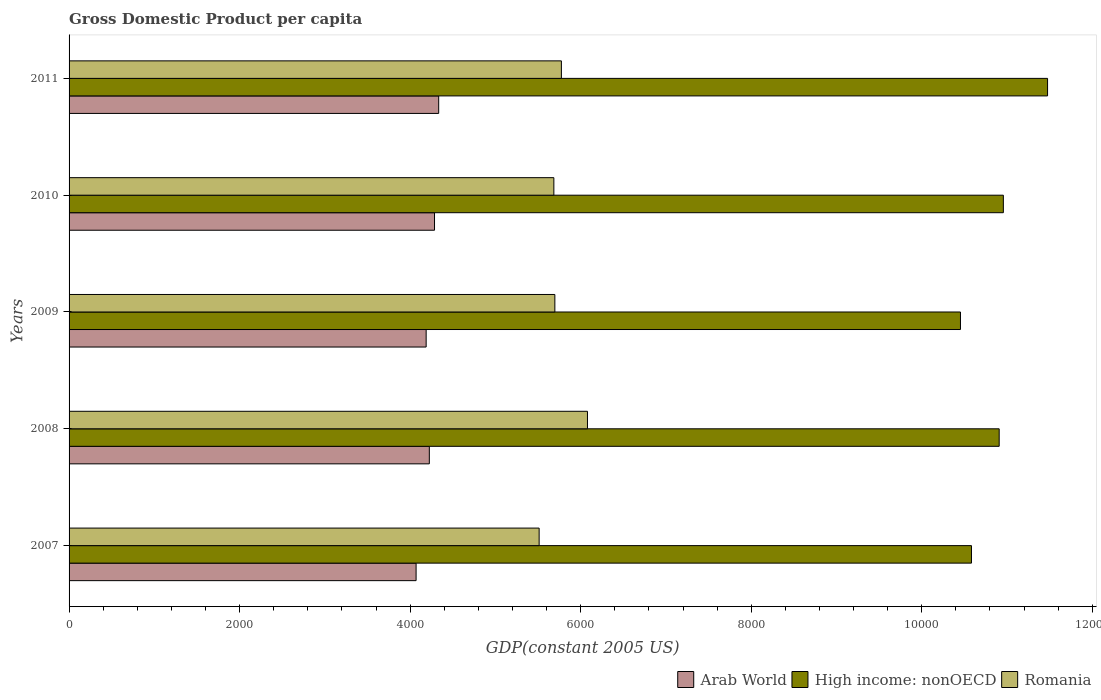How many different coloured bars are there?
Offer a very short reply. 3. Are the number of bars per tick equal to the number of legend labels?
Your answer should be compact. Yes. In how many cases, is the number of bars for a given year not equal to the number of legend labels?
Offer a very short reply. 0. What is the GDP per capita in Arab World in 2007?
Your answer should be compact. 4069.83. Across all years, what is the maximum GDP per capita in High income: nonOECD?
Give a very brief answer. 1.15e+04. Across all years, what is the minimum GDP per capita in Arab World?
Provide a short and direct response. 4069.83. In which year was the GDP per capita in High income: nonOECD maximum?
Your answer should be very brief. 2011. In which year was the GDP per capita in Arab World minimum?
Your response must be concise. 2007. What is the total GDP per capita in Romania in the graph?
Ensure brevity in your answer.  2.87e+04. What is the difference between the GDP per capita in Romania in 2010 and that in 2011?
Your answer should be very brief. -88.38. What is the difference between the GDP per capita in Romania in 2010 and the GDP per capita in High income: nonOECD in 2007?
Your answer should be very brief. -4897.54. What is the average GDP per capita in High income: nonOECD per year?
Keep it short and to the point. 1.09e+04. In the year 2007, what is the difference between the GDP per capita in High income: nonOECD and GDP per capita in Romania?
Make the answer very short. 5070.15. What is the ratio of the GDP per capita in High income: nonOECD in 2007 to that in 2010?
Give a very brief answer. 0.97. Is the difference between the GDP per capita in High income: nonOECD in 2009 and 2010 greater than the difference between the GDP per capita in Romania in 2009 and 2010?
Give a very brief answer. No. What is the difference between the highest and the second highest GDP per capita in High income: nonOECD?
Make the answer very short. 518.52. What is the difference between the highest and the lowest GDP per capita in Romania?
Offer a terse response. 566.79. In how many years, is the GDP per capita in High income: nonOECD greater than the average GDP per capita in High income: nonOECD taken over all years?
Provide a succinct answer. 3. Is the sum of the GDP per capita in High income: nonOECD in 2008 and 2010 greater than the maximum GDP per capita in Romania across all years?
Your answer should be very brief. Yes. What does the 3rd bar from the top in 2011 represents?
Provide a succinct answer. Arab World. What does the 3rd bar from the bottom in 2009 represents?
Provide a short and direct response. Romania. Are all the bars in the graph horizontal?
Give a very brief answer. Yes. How many legend labels are there?
Your answer should be very brief. 3. How are the legend labels stacked?
Keep it short and to the point. Horizontal. What is the title of the graph?
Provide a short and direct response. Gross Domestic Product per capita. Does "High income" appear as one of the legend labels in the graph?
Provide a succinct answer. No. What is the label or title of the X-axis?
Your answer should be very brief. GDP(constant 2005 US). What is the GDP(constant 2005 US) in Arab World in 2007?
Offer a very short reply. 4069.83. What is the GDP(constant 2005 US) of High income: nonOECD in 2007?
Provide a short and direct response. 1.06e+04. What is the GDP(constant 2005 US) of Romania in 2007?
Your answer should be very brief. 5512.77. What is the GDP(constant 2005 US) of Arab World in 2008?
Offer a very short reply. 4224.99. What is the GDP(constant 2005 US) of High income: nonOECD in 2008?
Keep it short and to the point. 1.09e+04. What is the GDP(constant 2005 US) in Romania in 2008?
Provide a succinct answer. 6079.56. What is the GDP(constant 2005 US) in Arab World in 2009?
Offer a terse response. 4187.73. What is the GDP(constant 2005 US) in High income: nonOECD in 2009?
Make the answer very short. 1.05e+04. What is the GDP(constant 2005 US) of Romania in 2009?
Give a very brief answer. 5697.19. What is the GDP(constant 2005 US) of Arab World in 2010?
Provide a succinct answer. 4285.82. What is the GDP(constant 2005 US) of High income: nonOECD in 2010?
Provide a short and direct response. 1.10e+04. What is the GDP(constant 2005 US) of Romania in 2010?
Make the answer very short. 5685.37. What is the GDP(constant 2005 US) in Arab World in 2011?
Offer a very short reply. 4334.68. What is the GDP(constant 2005 US) of High income: nonOECD in 2011?
Offer a very short reply. 1.15e+04. What is the GDP(constant 2005 US) of Romania in 2011?
Ensure brevity in your answer.  5773.76. Across all years, what is the maximum GDP(constant 2005 US) in Arab World?
Your response must be concise. 4334.68. Across all years, what is the maximum GDP(constant 2005 US) in High income: nonOECD?
Offer a terse response. 1.15e+04. Across all years, what is the maximum GDP(constant 2005 US) in Romania?
Your answer should be very brief. 6079.56. Across all years, what is the minimum GDP(constant 2005 US) in Arab World?
Your response must be concise. 4069.83. Across all years, what is the minimum GDP(constant 2005 US) of High income: nonOECD?
Provide a succinct answer. 1.05e+04. Across all years, what is the minimum GDP(constant 2005 US) in Romania?
Provide a short and direct response. 5512.77. What is the total GDP(constant 2005 US) of Arab World in the graph?
Your answer should be very brief. 2.11e+04. What is the total GDP(constant 2005 US) of High income: nonOECD in the graph?
Offer a very short reply. 5.44e+04. What is the total GDP(constant 2005 US) in Romania in the graph?
Your answer should be very brief. 2.87e+04. What is the difference between the GDP(constant 2005 US) in Arab World in 2007 and that in 2008?
Your answer should be compact. -155.16. What is the difference between the GDP(constant 2005 US) of High income: nonOECD in 2007 and that in 2008?
Provide a short and direct response. -325.05. What is the difference between the GDP(constant 2005 US) of Romania in 2007 and that in 2008?
Your response must be concise. -566.79. What is the difference between the GDP(constant 2005 US) of Arab World in 2007 and that in 2009?
Offer a terse response. -117.9. What is the difference between the GDP(constant 2005 US) of High income: nonOECD in 2007 and that in 2009?
Your response must be concise. 128.96. What is the difference between the GDP(constant 2005 US) in Romania in 2007 and that in 2009?
Give a very brief answer. -184.43. What is the difference between the GDP(constant 2005 US) in Arab World in 2007 and that in 2010?
Your answer should be very brief. -215.99. What is the difference between the GDP(constant 2005 US) in High income: nonOECD in 2007 and that in 2010?
Make the answer very short. -373.98. What is the difference between the GDP(constant 2005 US) in Romania in 2007 and that in 2010?
Keep it short and to the point. -172.61. What is the difference between the GDP(constant 2005 US) of Arab World in 2007 and that in 2011?
Make the answer very short. -264.85. What is the difference between the GDP(constant 2005 US) of High income: nonOECD in 2007 and that in 2011?
Your response must be concise. -892.5. What is the difference between the GDP(constant 2005 US) of Romania in 2007 and that in 2011?
Keep it short and to the point. -260.99. What is the difference between the GDP(constant 2005 US) in Arab World in 2008 and that in 2009?
Provide a short and direct response. 37.26. What is the difference between the GDP(constant 2005 US) of High income: nonOECD in 2008 and that in 2009?
Provide a short and direct response. 454.01. What is the difference between the GDP(constant 2005 US) of Romania in 2008 and that in 2009?
Provide a short and direct response. 382.37. What is the difference between the GDP(constant 2005 US) of Arab World in 2008 and that in 2010?
Provide a succinct answer. -60.83. What is the difference between the GDP(constant 2005 US) of High income: nonOECD in 2008 and that in 2010?
Your response must be concise. -48.93. What is the difference between the GDP(constant 2005 US) in Romania in 2008 and that in 2010?
Keep it short and to the point. 394.19. What is the difference between the GDP(constant 2005 US) in Arab World in 2008 and that in 2011?
Ensure brevity in your answer.  -109.69. What is the difference between the GDP(constant 2005 US) of High income: nonOECD in 2008 and that in 2011?
Make the answer very short. -567.45. What is the difference between the GDP(constant 2005 US) of Romania in 2008 and that in 2011?
Your answer should be compact. 305.8. What is the difference between the GDP(constant 2005 US) of Arab World in 2009 and that in 2010?
Your response must be concise. -98.09. What is the difference between the GDP(constant 2005 US) of High income: nonOECD in 2009 and that in 2010?
Make the answer very short. -502.94. What is the difference between the GDP(constant 2005 US) of Romania in 2009 and that in 2010?
Offer a very short reply. 11.82. What is the difference between the GDP(constant 2005 US) in Arab World in 2009 and that in 2011?
Provide a succinct answer. -146.95. What is the difference between the GDP(constant 2005 US) of High income: nonOECD in 2009 and that in 2011?
Keep it short and to the point. -1021.46. What is the difference between the GDP(constant 2005 US) in Romania in 2009 and that in 2011?
Your answer should be compact. -76.56. What is the difference between the GDP(constant 2005 US) in Arab World in 2010 and that in 2011?
Keep it short and to the point. -48.86. What is the difference between the GDP(constant 2005 US) in High income: nonOECD in 2010 and that in 2011?
Provide a short and direct response. -518.52. What is the difference between the GDP(constant 2005 US) of Romania in 2010 and that in 2011?
Give a very brief answer. -88.38. What is the difference between the GDP(constant 2005 US) in Arab World in 2007 and the GDP(constant 2005 US) in High income: nonOECD in 2008?
Provide a succinct answer. -6838.14. What is the difference between the GDP(constant 2005 US) of Arab World in 2007 and the GDP(constant 2005 US) of Romania in 2008?
Make the answer very short. -2009.73. What is the difference between the GDP(constant 2005 US) in High income: nonOECD in 2007 and the GDP(constant 2005 US) in Romania in 2008?
Your answer should be very brief. 4503.36. What is the difference between the GDP(constant 2005 US) in Arab World in 2007 and the GDP(constant 2005 US) in High income: nonOECD in 2009?
Your answer should be compact. -6384.13. What is the difference between the GDP(constant 2005 US) of Arab World in 2007 and the GDP(constant 2005 US) of Romania in 2009?
Provide a succinct answer. -1627.36. What is the difference between the GDP(constant 2005 US) in High income: nonOECD in 2007 and the GDP(constant 2005 US) in Romania in 2009?
Your response must be concise. 4885.72. What is the difference between the GDP(constant 2005 US) of Arab World in 2007 and the GDP(constant 2005 US) of High income: nonOECD in 2010?
Offer a terse response. -6887.07. What is the difference between the GDP(constant 2005 US) in Arab World in 2007 and the GDP(constant 2005 US) in Romania in 2010?
Offer a very short reply. -1615.54. What is the difference between the GDP(constant 2005 US) of High income: nonOECD in 2007 and the GDP(constant 2005 US) of Romania in 2010?
Give a very brief answer. 4897.54. What is the difference between the GDP(constant 2005 US) of Arab World in 2007 and the GDP(constant 2005 US) of High income: nonOECD in 2011?
Provide a short and direct response. -7405.59. What is the difference between the GDP(constant 2005 US) of Arab World in 2007 and the GDP(constant 2005 US) of Romania in 2011?
Provide a succinct answer. -1703.93. What is the difference between the GDP(constant 2005 US) of High income: nonOECD in 2007 and the GDP(constant 2005 US) of Romania in 2011?
Provide a short and direct response. 4809.16. What is the difference between the GDP(constant 2005 US) of Arab World in 2008 and the GDP(constant 2005 US) of High income: nonOECD in 2009?
Your answer should be compact. -6228.97. What is the difference between the GDP(constant 2005 US) in Arab World in 2008 and the GDP(constant 2005 US) in Romania in 2009?
Ensure brevity in your answer.  -1472.21. What is the difference between the GDP(constant 2005 US) of High income: nonOECD in 2008 and the GDP(constant 2005 US) of Romania in 2009?
Your response must be concise. 5210.77. What is the difference between the GDP(constant 2005 US) in Arab World in 2008 and the GDP(constant 2005 US) in High income: nonOECD in 2010?
Your response must be concise. -6731.91. What is the difference between the GDP(constant 2005 US) of Arab World in 2008 and the GDP(constant 2005 US) of Romania in 2010?
Provide a succinct answer. -1460.38. What is the difference between the GDP(constant 2005 US) of High income: nonOECD in 2008 and the GDP(constant 2005 US) of Romania in 2010?
Ensure brevity in your answer.  5222.59. What is the difference between the GDP(constant 2005 US) of Arab World in 2008 and the GDP(constant 2005 US) of High income: nonOECD in 2011?
Ensure brevity in your answer.  -7250.43. What is the difference between the GDP(constant 2005 US) of Arab World in 2008 and the GDP(constant 2005 US) of Romania in 2011?
Offer a very short reply. -1548.77. What is the difference between the GDP(constant 2005 US) of High income: nonOECD in 2008 and the GDP(constant 2005 US) of Romania in 2011?
Make the answer very short. 5134.21. What is the difference between the GDP(constant 2005 US) of Arab World in 2009 and the GDP(constant 2005 US) of High income: nonOECD in 2010?
Offer a terse response. -6769.17. What is the difference between the GDP(constant 2005 US) in Arab World in 2009 and the GDP(constant 2005 US) in Romania in 2010?
Your response must be concise. -1497.64. What is the difference between the GDP(constant 2005 US) in High income: nonOECD in 2009 and the GDP(constant 2005 US) in Romania in 2010?
Provide a short and direct response. 4768.59. What is the difference between the GDP(constant 2005 US) of Arab World in 2009 and the GDP(constant 2005 US) of High income: nonOECD in 2011?
Offer a very short reply. -7287.69. What is the difference between the GDP(constant 2005 US) in Arab World in 2009 and the GDP(constant 2005 US) in Romania in 2011?
Offer a very short reply. -1586.03. What is the difference between the GDP(constant 2005 US) in High income: nonOECD in 2009 and the GDP(constant 2005 US) in Romania in 2011?
Ensure brevity in your answer.  4680.2. What is the difference between the GDP(constant 2005 US) of Arab World in 2010 and the GDP(constant 2005 US) of High income: nonOECD in 2011?
Give a very brief answer. -7189.6. What is the difference between the GDP(constant 2005 US) in Arab World in 2010 and the GDP(constant 2005 US) in Romania in 2011?
Give a very brief answer. -1487.94. What is the difference between the GDP(constant 2005 US) of High income: nonOECD in 2010 and the GDP(constant 2005 US) of Romania in 2011?
Make the answer very short. 5183.14. What is the average GDP(constant 2005 US) of Arab World per year?
Your response must be concise. 4220.61. What is the average GDP(constant 2005 US) of High income: nonOECD per year?
Your response must be concise. 1.09e+04. What is the average GDP(constant 2005 US) in Romania per year?
Your answer should be compact. 5749.73. In the year 2007, what is the difference between the GDP(constant 2005 US) of Arab World and GDP(constant 2005 US) of High income: nonOECD?
Make the answer very short. -6513.09. In the year 2007, what is the difference between the GDP(constant 2005 US) of Arab World and GDP(constant 2005 US) of Romania?
Offer a terse response. -1442.94. In the year 2007, what is the difference between the GDP(constant 2005 US) in High income: nonOECD and GDP(constant 2005 US) in Romania?
Offer a terse response. 5070.15. In the year 2008, what is the difference between the GDP(constant 2005 US) of Arab World and GDP(constant 2005 US) of High income: nonOECD?
Make the answer very short. -6682.98. In the year 2008, what is the difference between the GDP(constant 2005 US) in Arab World and GDP(constant 2005 US) in Romania?
Your answer should be compact. -1854.57. In the year 2008, what is the difference between the GDP(constant 2005 US) in High income: nonOECD and GDP(constant 2005 US) in Romania?
Make the answer very short. 4828.41. In the year 2009, what is the difference between the GDP(constant 2005 US) in Arab World and GDP(constant 2005 US) in High income: nonOECD?
Give a very brief answer. -6266.23. In the year 2009, what is the difference between the GDP(constant 2005 US) of Arab World and GDP(constant 2005 US) of Romania?
Your answer should be compact. -1509.46. In the year 2009, what is the difference between the GDP(constant 2005 US) of High income: nonOECD and GDP(constant 2005 US) of Romania?
Your answer should be very brief. 4756.77. In the year 2010, what is the difference between the GDP(constant 2005 US) in Arab World and GDP(constant 2005 US) in High income: nonOECD?
Your answer should be very brief. -6671.08. In the year 2010, what is the difference between the GDP(constant 2005 US) in Arab World and GDP(constant 2005 US) in Romania?
Offer a very short reply. -1399.55. In the year 2010, what is the difference between the GDP(constant 2005 US) of High income: nonOECD and GDP(constant 2005 US) of Romania?
Offer a very short reply. 5271.53. In the year 2011, what is the difference between the GDP(constant 2005 US) in Arab World and GDP(constant 2005 US) in High income: nonOECD?
Offer a terse response. -7140.74. In the year 2011, what is the difference between the GDP(constant 2005 US) in Arab World and GDP(constant 2005 US) in Romania?
Ensure brevity in your answer.  -1439.08. In the year 2011, what is the difference between the GDP(constant 2005 US) of High income: nonOECD and GDP(constant 2005 US) of Romania?
Offer a very short reply. 5701.66. What is the ratio of the GDP(constant 2005 US) in Arab World in 2007 to that in 2008?
Ensure brevity in your answer.  0.96. What is the ratio of the GDP(constant 2005 US) in High income: nonOECD in 2007 to that in 2008?
Offer a terse response. 0.97. What is the ratio of the GDP(constant 2005 US) of Romania in 2007 to that in 2008?
Your answer should be compact. 0.91. What is the ratio of the GDP(constant 2005 US) of Arab World in 2007 to that in 2009?
Keep it short and to the point. 0.97. What is the ratio of the GDP(constant 2005 US) of High income: nonOECD in 2007 to that in 2009?
Provide a succinct answer. 1.01. What is the ratio of the GDP(constant 2005 US) of Romania in 2007 to that in 2009?
Give a very brief answer. 0.97. What is the ratio of the GDP(constant 2005 US) in Arab World in 2007 to that in 2010?
Give a very brief answer. 0.95. What is the ratio of the GDP(constant 2005 US) of High income: nonOECD in 2007 to that in 2010?
Your answer should be very brief. 0.97. What is the ratio of the GDP(constant 2005 US) of Romania in 2007 to that in 2010?
Provide a short and direct response. 0.97. What is the ratio of the GDP(constant 2005 US) in Arab World in 2007 to that in 2011?
Offer a very short reply. 0.94. What is the ratio of the GDP(constant 2005 US) of High income: nonOECD in 2007 to that in 2011?
Your answer should be very brief. 0.92. What is the ratio of the GDP(constant 2005 US) of Romania in 2007 to that in 2011?
Give a very brief answer. 0.95. What is the ratio of the GDP(constant 2005 US) of Arab World in 2008 to that in 2009?
Offer a very short reply. 1.01. What is the ratio of the GDP(constant 2005 US) of High income: nonOECD in 2008 to that in 2009?
Keep it short and to the point. 1.04. What is the ratio of the GDP(constant 2005 US) of Romania in 2008 to that in 2009?
Your response must be concise. 1.07. What is the ratio of the GDP(constant 2005 US) of Arab World in 2008 to that in 2010?
Give a very brief answer. 0.99. What is the ratio of the GDP(constant 2005 US) in High income: nonOECD in 2008 to that in 2010?
Offer a very short reply. 1. What is the ratio of the GDP(constant 2005 US) of Romania in 2008 to that in 2010?
Provide a short and direct response. 1.07. What is the ratio of the GDP(constant 2005 US) in Arab World in 2008 to that in 2011?
Your response must be concise. 0.97. What is the ratio of the GDP(constant 2005 US) in High income: nonOECD in 2008 to that in 2011?
Provide a short and direct response. 0.95. What is the ratio of the GDP(constant 2005 US) of Romania in 2008 to that in 2011?
Offer a terse response. 1.05. What is the ratio of the GDP(constant 2005 US) in Arab World in 2009 to that in 2010?
Your answer should be compact. 0.98. What is the ratio of the GDP(constant 2005 US) of High income: nonOECD in 2009 to that in 2010?
Your answer should be very brief. 0.95. What is the ratio of the GDP(constant 2005 US) in Arab World in 2009 to that in 2011?
Offer a very short reply. 0.97. What is the ratio of the GDP(constant 2005 US) in High income: nonOECD in 2009 to that in 2011?
Ensure brevity in your answer.  0.91. What is the ratio of the GDP(constant 2005 US) of Romania in 2009 to that in 2011?
Your answer should be compact. 0.99. What is the ratio of the GDP(constant 2005 US) of Arab World in 2010 to that in 2011?
Offer a very short reply. 0.99. What is the ratio of the GDP(constant 2005 US) of High income: nonOECD in 2010 to that in 2011?
Make the answer very short. 0.95. What is the ratio of the GDP(constant 2005 US) of Romania in 2010 to that in 2011?
Your answer should be very brief. 0.98. What is the difference between the highest and the second highest GDP(constant 2005 US) in Arab World?
Offer a very short reply. 48.86. What is the difference between the highest and the second highest GDP(constant 2005 US) in High income: nonOECD?
Your answer should be very brief. 518.52. What is the difference between the highest and the second highest GDP(constant 2005 US) of Romania?
Keep it short and to the point. 305.8. What is the difference between the highest and the lowest GDP(constant 2005 US) of Arab World?
Your answer should be very brief. 264.85. What is the difference between the highest and the lowest GDP(constant 2005 US) in High income: nonOECD?
Your answer should be very brief. 1021.46. What is the difference between the highest and the lowest GDP(constant 2005 US) of Romania?
Keep it short and to the point. 566.79. 